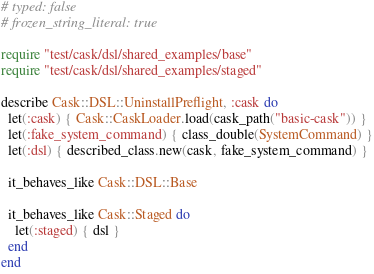<code> <loc_0><loc_0><loc_500><loc_500><_Ruby_># typed: false
# frozen_string_literal: true

require "test/cask/dsl/shared_examples/base"
require "test/cask/dsl/shared_examples/staged"

describe Cask::DSL::UninstallPreflight, :cask do
  let(:cask) { Cask::CaskLoader.load(cask_path("basic-cask")) }
  let(:fake_system_command) { class_double(SystemCommand) }
  let(:dsl) { described_class.new(cask, fake_system_command) }

  it_behaves_like Cask::DSL::Base

  it_behaves_like Cask::Staged do
    let(:staged) { dsl }
  end
end
</code> 